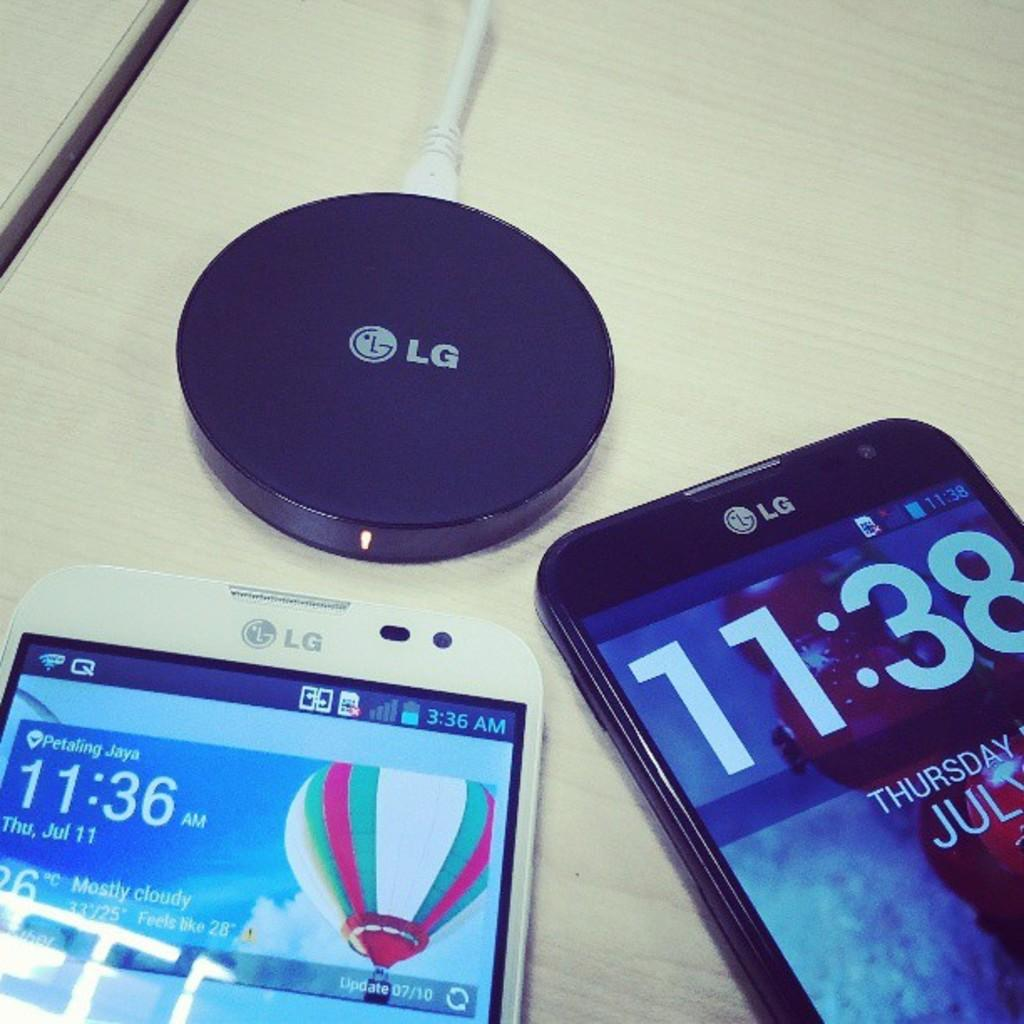<image>
Present a compact description of the photo's key features. A charging station and two LG smart phones displayed on the table. 